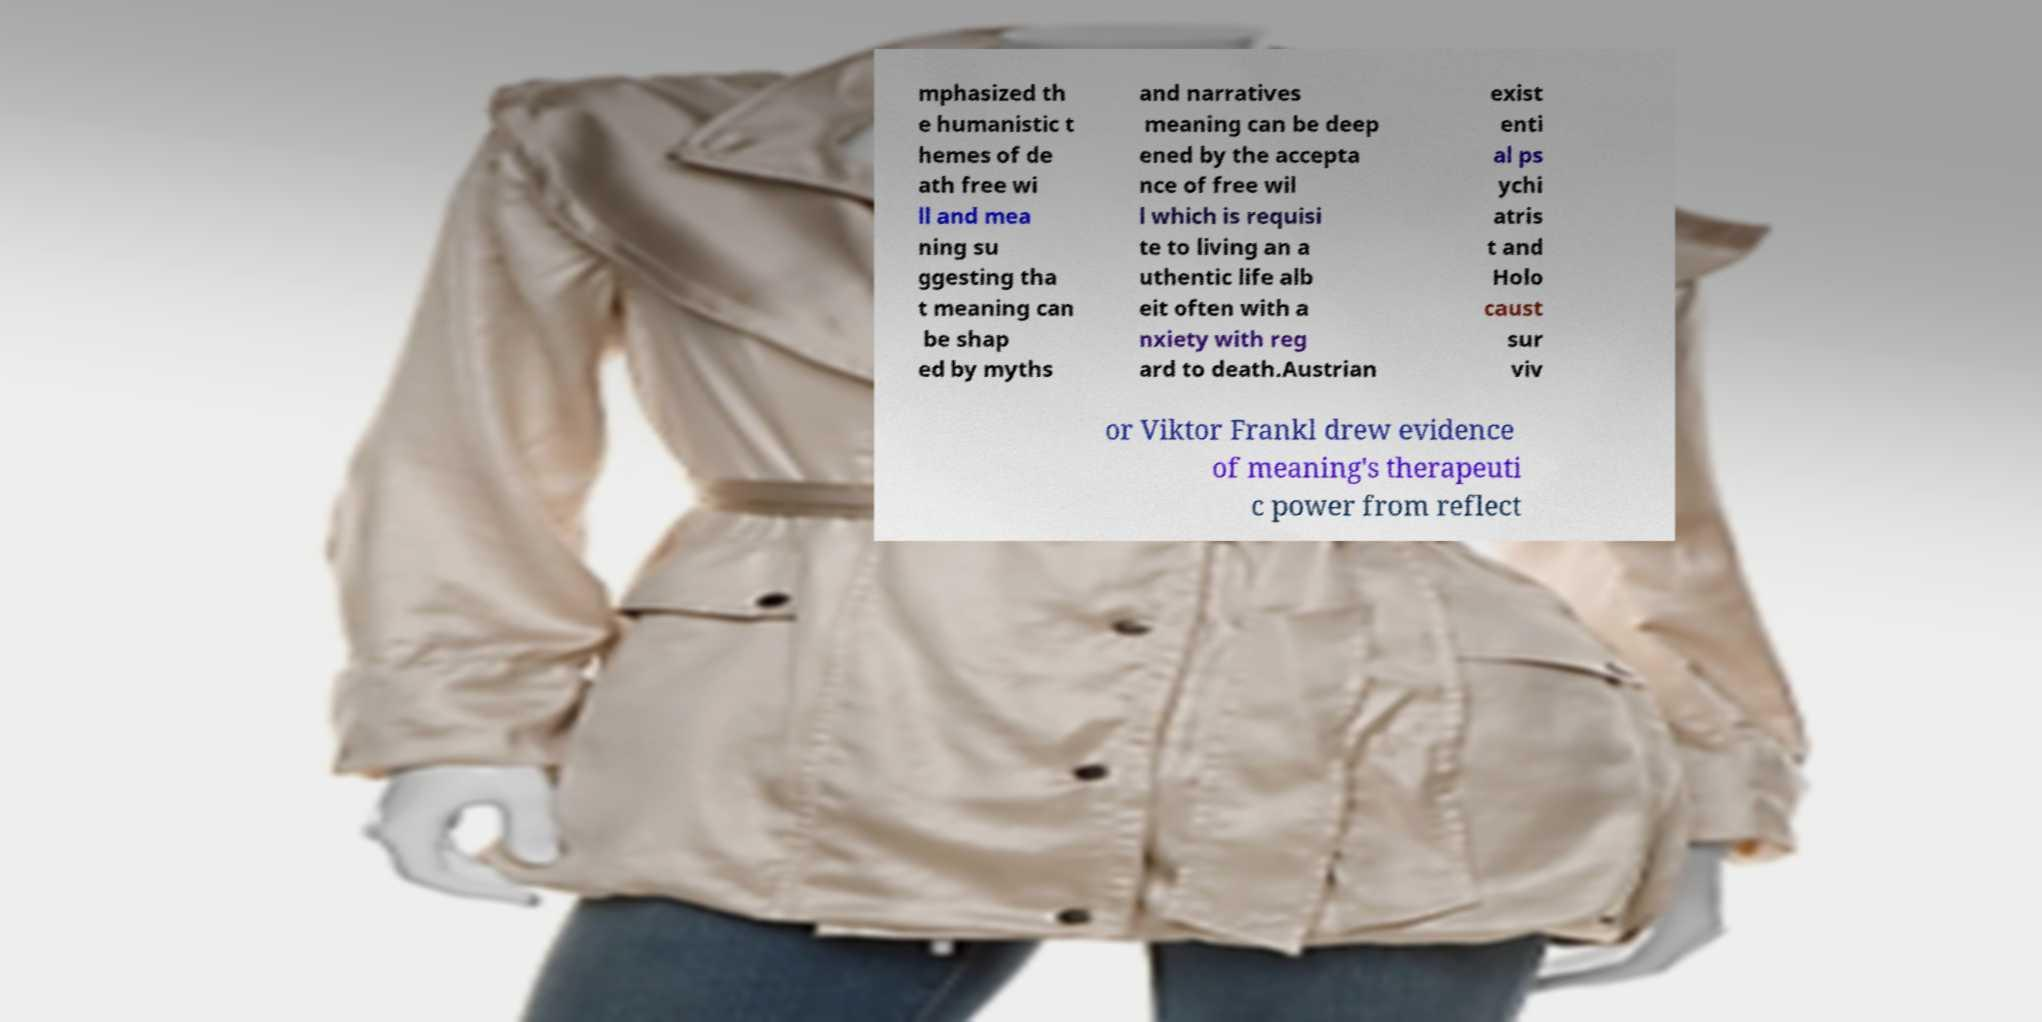What messages or text are displayed in this image? I need them in a readable, typed format. mphasized th e humanistic t hemes of de ath free wi ll and mea ning su ggesting tha t meaning can be shap ed by myths and narratives meaning can be deep ened by the accepta nce of free wil l which is requisi te to living an a uthentic life alb eit often with a nxiety with reg ard to death.Austrian exist enti al ps ychi atris t and Holo caust sur viv or Viktor Frankl drew evidence of meaning's therapeuti c power from reflect 